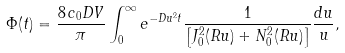<formula> <loc_0><loc_0><loc_500><loc_500>\Phi ( t ) = \frac { 8 \, c _ { 0 } D V } { \pi } \int _ { 0 } ^ { \infty } e ^ { - D u ^ { 2 } t } \frac { 1 } { \left [ J _ { 0 } ^ { 2 } ( R u ) + N _ { 0 } ^ { 2 } ( R u ) \right ] } \frac { d u } { u } ,</formula> 